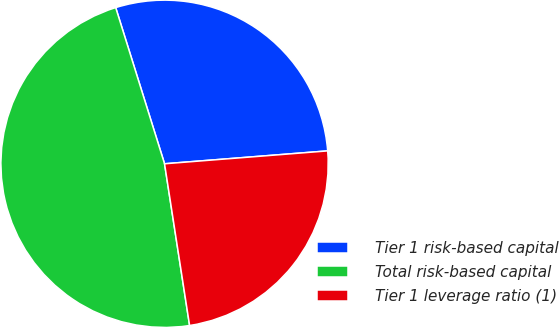Convert chart to OTSL. <chart><loc_0><loc_0><loc_500><loc_500><pie_chart><fcel>Tier 1 risk-based capital<fcel>Total risk-based capital<fcel>Tier 1 leverage ratio (1)<nl><fcel>28.57%<fcel>47.62%<fcel>23.81%<nl></chart> 